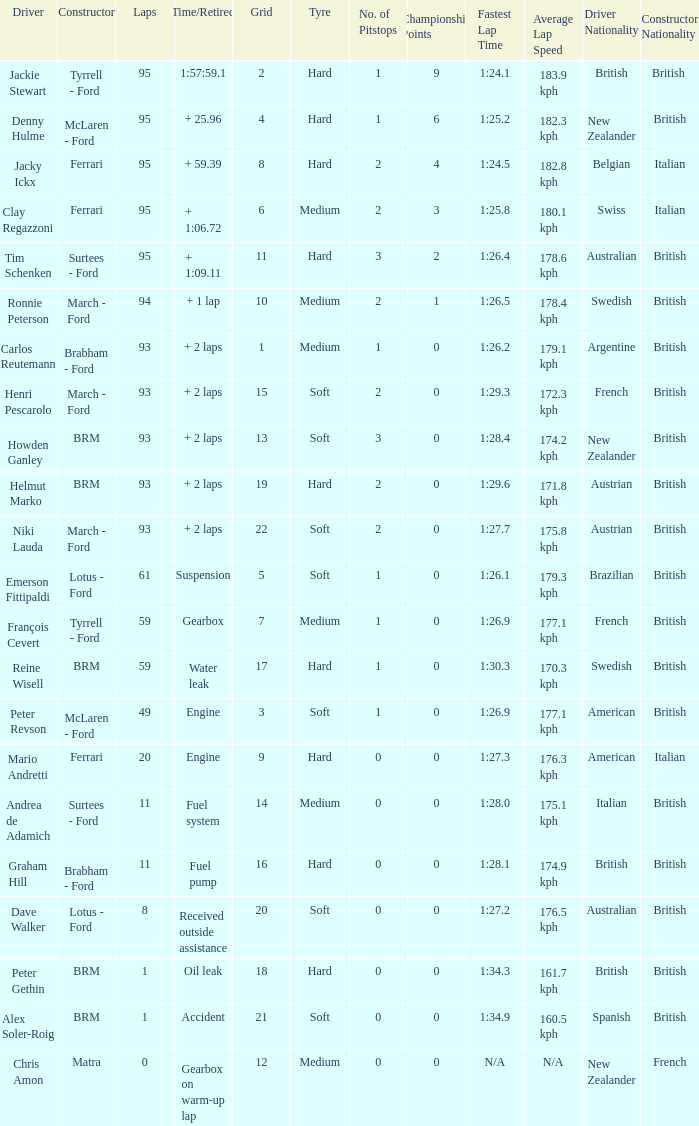What is the largest number of laps with a Grid larger than 14, a Time/Retired of + 2 laps, and a Driver of helmut marko? 93.0. 